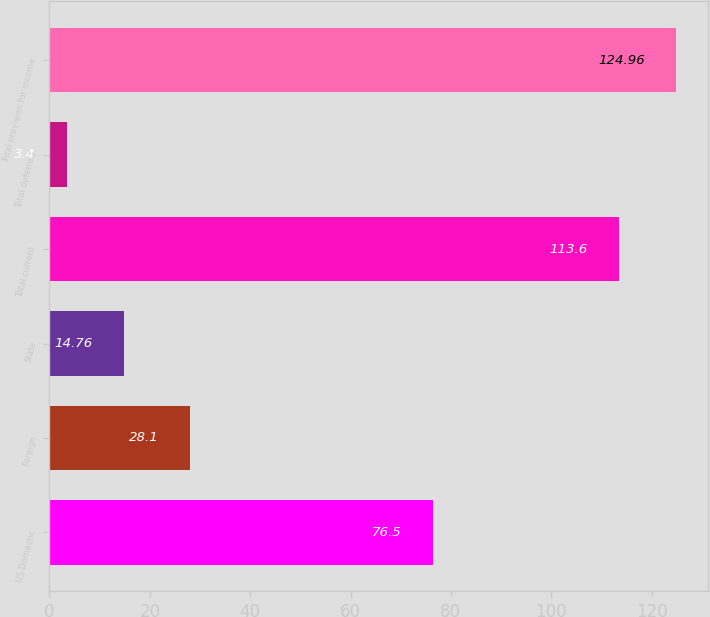<chart> <loc_0><loc_0><loc_500><loc_500><bar_chart><fcel>US Domestic<fcel>Foreign<fcel>State<fcel>Total current<fcel>Total deferred<fcel>Total provision for income<nl><fcel>76.5<fcel>28.1<fcel>14.76<fcel>113.6<fcel>3.4<fcel>124.96<nl></chart> 